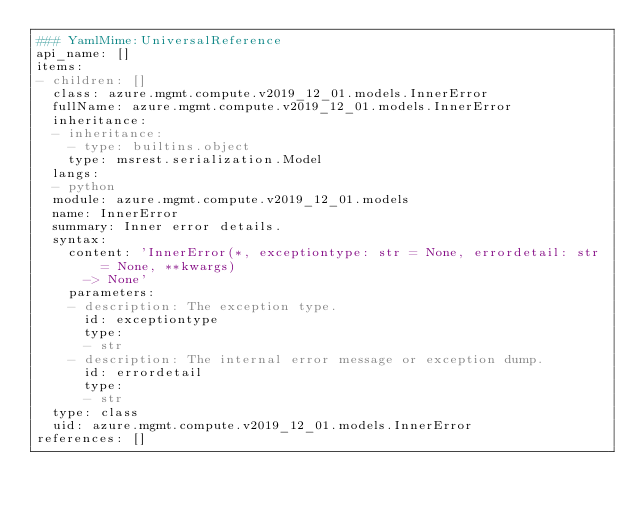<code> <loc_0><loc_0><loc_500><loc_500><_YAML_>### YamlMime:UniversalReference
api_name: []
items:
- children: []
  class: azure.mgmt.compute.v2019_12_01.models.InnerError
  fullName: azure.mgmt.compute.v2019_12_01.models.InnerError
  inheritance:
  - inheritance:
    - type: builtins.object
    type: msrest.serialization.Model
  langs:
  - python
  module: azure.mgmt.compute.v2019_12_01.models
  name: InnerError
  summary: Inner error details.
  syntax:
    content: 'InnerError(*, exceptiontype: str = None, errordetail: str = None, **kwargs)
      -> None'
    parameters:
    - description: The exception type.
      id: exceptiontype
      type:
      - str
    - description: The internal error message or exception dump.
      id: errordetail
      type:
      - str
  type: class
  uid: azure.mgmt.compute.v2019_12_01.models.InnerError
references: []
</code> 